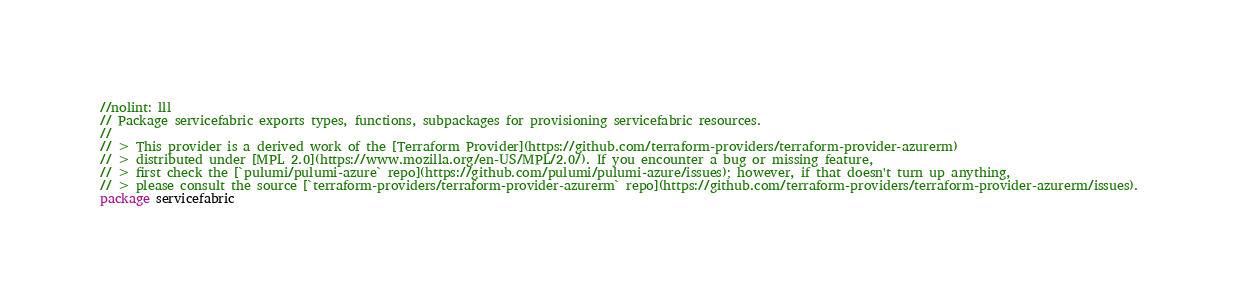<code> <loc_0><loc_0><loc_500><loc_500><_Go_>//nolint: lll
// Package servicefabric exports types, functions, subpackages for provisioning servicefabric resources.
//
// > This provider is a derived work of the [Terraform Provider](https://github.com/terraform-providers/terraform-provider-azurerm)
// > distributed under [MPL 2.0](https://www.mozilla.org/en-US/MPL/2.0/). If you encounter a bug or missing feature,
// > first check the [`pulumi/pulumi-azure` repo](https://github.com/pulumi/pulumi-azure/issues); however, if that doesn't turn up anything,
// > please consult the source [`terraform-providers/terraform-provider-azurerm` repo](https://github.com/terraform-providers/terraform-provider-azurerm/issues).
package servicefabric
</code> 